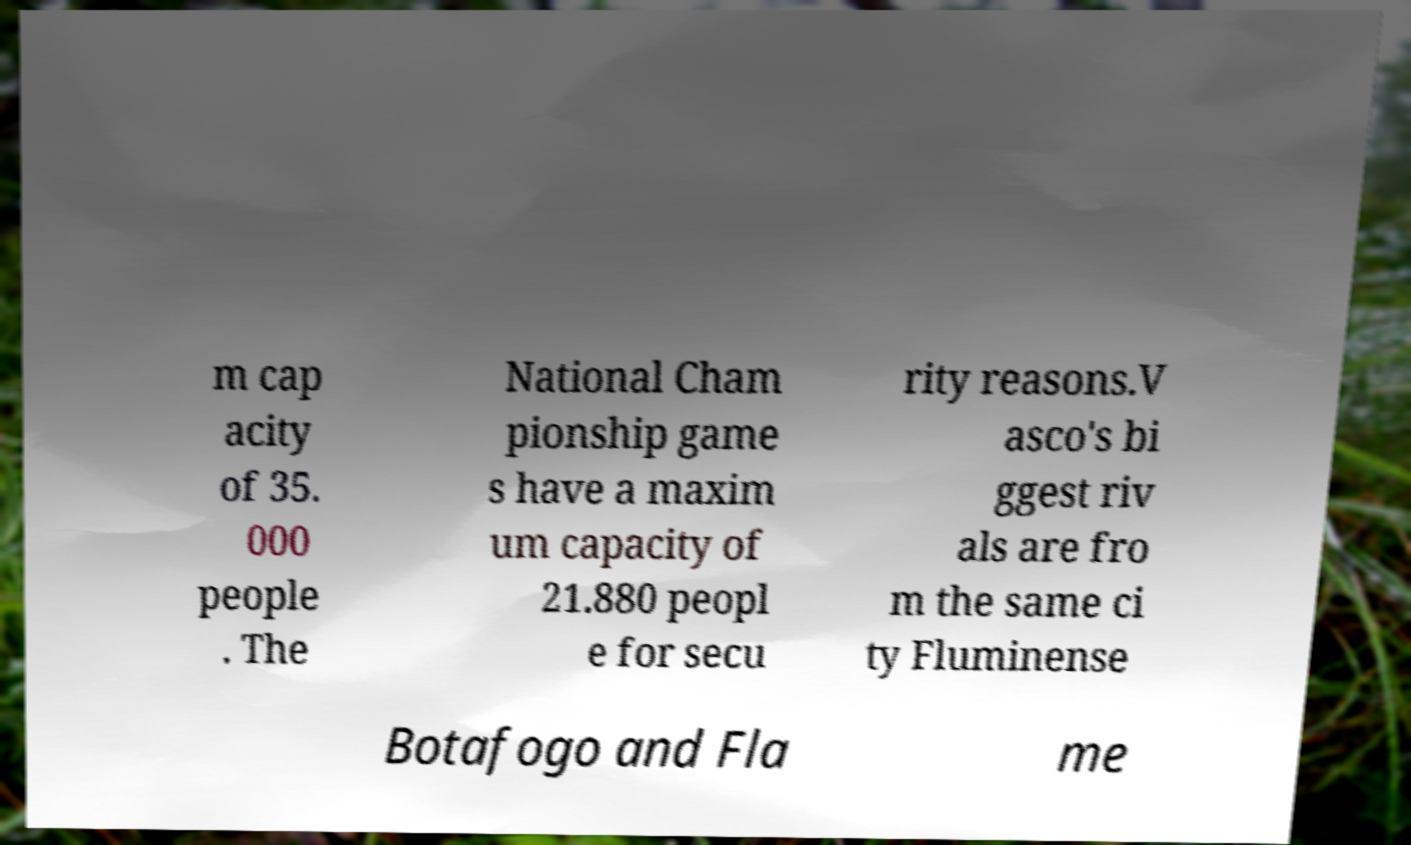Could you extract and type out the text from this image? m cap acity of 35. 000 people . The National Cham pionship game s have a maxim um capacity of 21.880 peopl e for secu rity reasons.V asco's bi ggest riv als are fro m the same ci ty Fluminense Botafogo and Fla me 